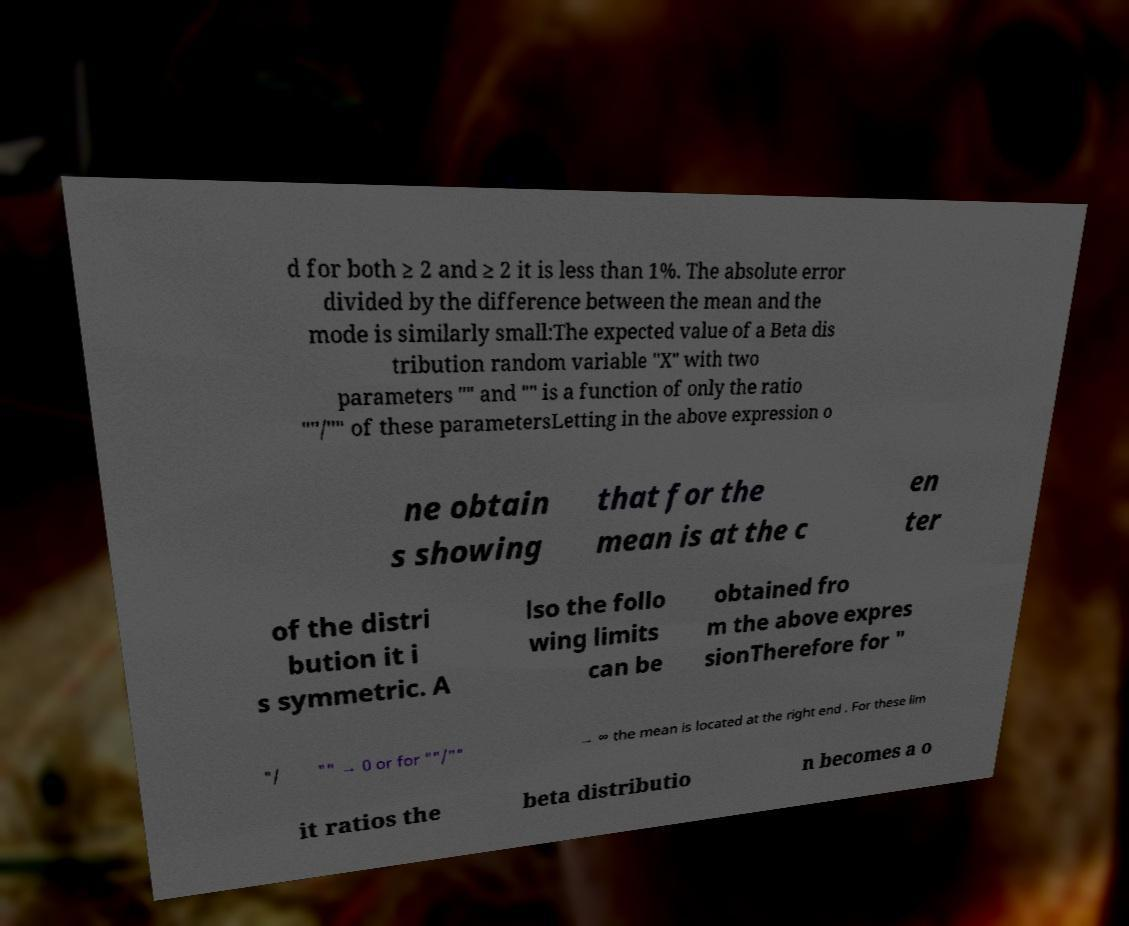For documentation purposes, I need the text within this image transcribed. Could you provide that? d for both ≥ 2 and ≥ 2 it is less than 1%. The absolute error divided by the difference between the mean and the mode is similarly small:The expected value of a Beta dis tribution random variable "X" with two parameters "" and "" is a function of only the ratio ""/"" of these parametersLetting in the above expression o ne obtain s showing that for the mean is at the c en ter of the distri bution it i s symmetric. A lso the follo wing limits can be obtained fro m the above expres sionTherefore for " "/ "" → 0 or for ""/"" → ∞ the mean is located at the right end . For these lim it ratios the beta distributio n becomes a o 